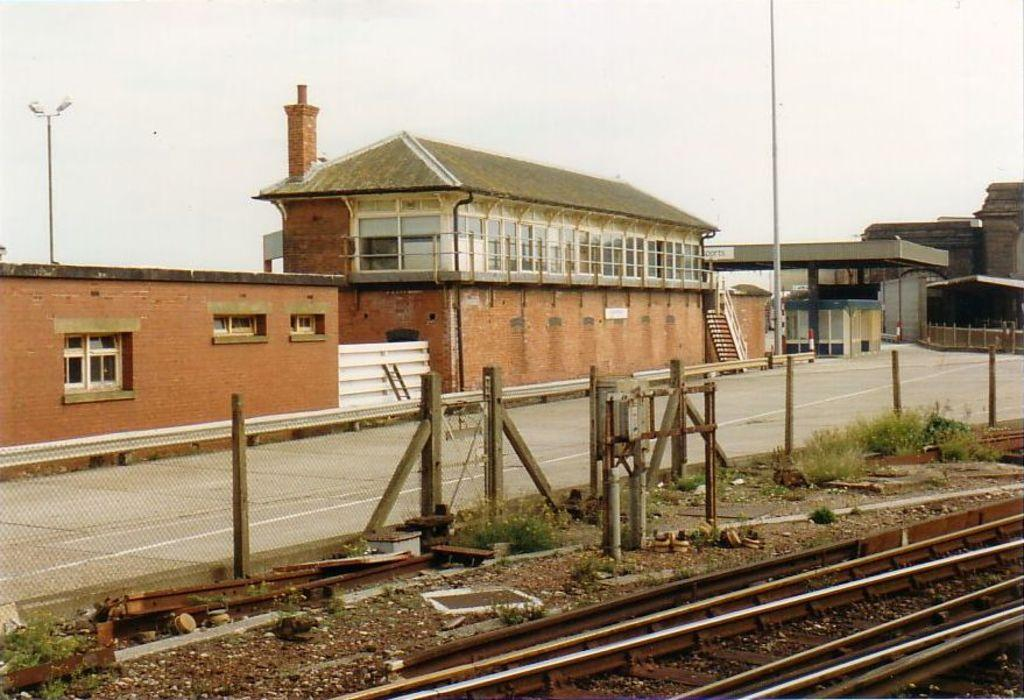What type of structures can be seen in the image? There are buildings in the image. Can you describe a specific architectural feature in the image? There is a staircase in the image. What type of material is present in the image? There is a mesh in the image. What type of vegetation is visible in the image? There are shrubs in the image. What is the ground like in the image? The ground is visible in the image. What type of transportation infrastructure is present in the image? There is a railway track in the image. What type of vertical structures are present in the image? There are poles in the image. What type of lighting is present in the image? There are street lights in the image. What type of industrial structure is present in the image? There is a chimney in the image. What part of the natural environment is visible in the image? The sky is visible in the image. What type of comb is used to style the hair of the buildings in the image? There is no comb present in the image, and buildings do not have hair. What type of channel can be seen running through the image? There is no channel present in the image. 